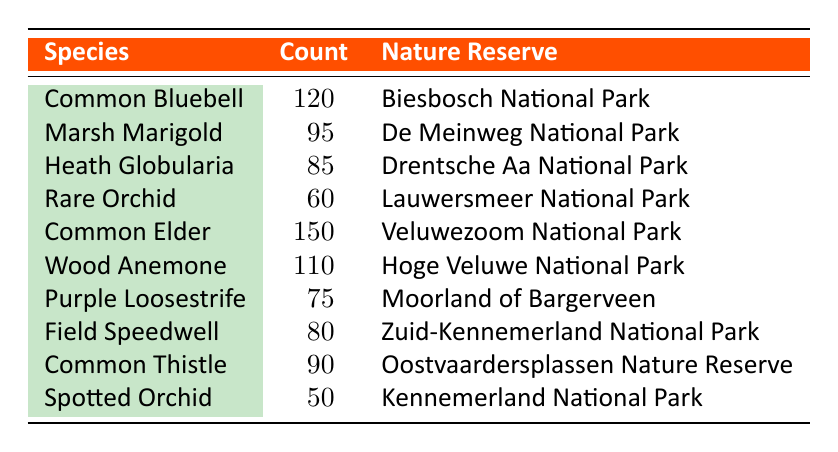What is the species with the highest count in the table? The highest count in the table is found under the 'Count' column. Scanning through the values, I see that the 'Common Elder' has the highest count of 150.
Answer: Common Elder Which nature reserve has the least number of species counted? The table lists the counts for each species in different nature reserves. The 'Spotted Orchid' has the lowest count of 50, which is linked to 'Kennemerland National Park'. Therefore, it is the reserve with the least number of species counted.
Answer: Kennemerland National Park What is the total count of the species in 'Veluwezoom National Park'? 'Veluwezoom National Park' contains 'Common Elder', which has a count of 150. There are no other species listed in this reserve, so the total count is simply 150.
Answer: 150 How many species have a count greater than 80? By reviewing the counts, I can see the species with counts greater than 80: 'Common Bluebell' (120), 'Common Elder' (150), 'Wood Anemone' (110), 'Marsh Marigold' (95), and 'Common Thistle' (90). Counting these gives a total of 5 species.
Answer: 5 Is the 'Rare Orchid' count higher than that of the 'Heath Globularia'? Comparing the counts, the 'Rare Orchid' has a count of 60, while the 'Heath Globularia' has a count of 85. 60 is not greater than 85, hence the statement is false.
Answer: No What is the average count of all species in 'Hoge Veluwe National Park'? 'Hoge Veluwe National Park' lists 'Wood Anemone' with a count of 110. Since it's the only species recorded here, the average is simply 110/1 = 110.
Answer: 110 Which species have counts that sum to less than 100? Summing the counts of 'Spotted Orchid' (50) and 'Purple Loosestrife' (75), we find that their total is 125, which is not less than 100. However, the individual 'Spotted Orchid' (50) and 'Rare Orchid' (60) never exceed 100. Therefore, only 'Spotted Orchid' is less than 100.
Answer: Spotted Orchid Which nature reserve has more than one species listed, and what are they? Upon reviewing the table, I find that there are no reserves with more than one species since each entry corresponds to a different reserve. Each reserve listed has only one species associated with it.
Answer: None 